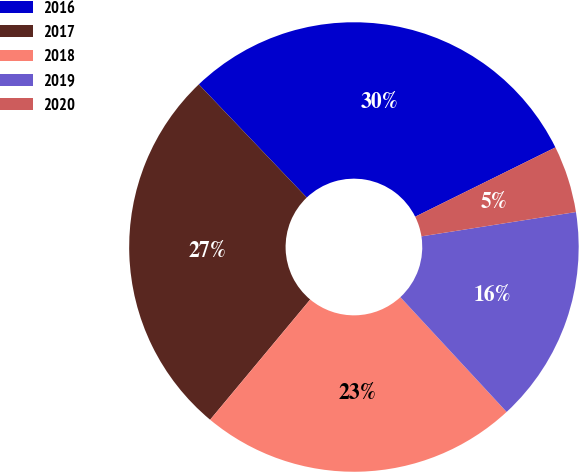Convert chart. <chart><loc_0><loc_0><loc_500><loc_500><pie_chart><fcel>2016<fcel>2017<fcel>2018<fcel>2019<fcel>2020<nl><fcel>29.82%<fcel>26.83%<fcel>22.94%<fcel>15.6%<fcel>4.82%<nl></chart> 